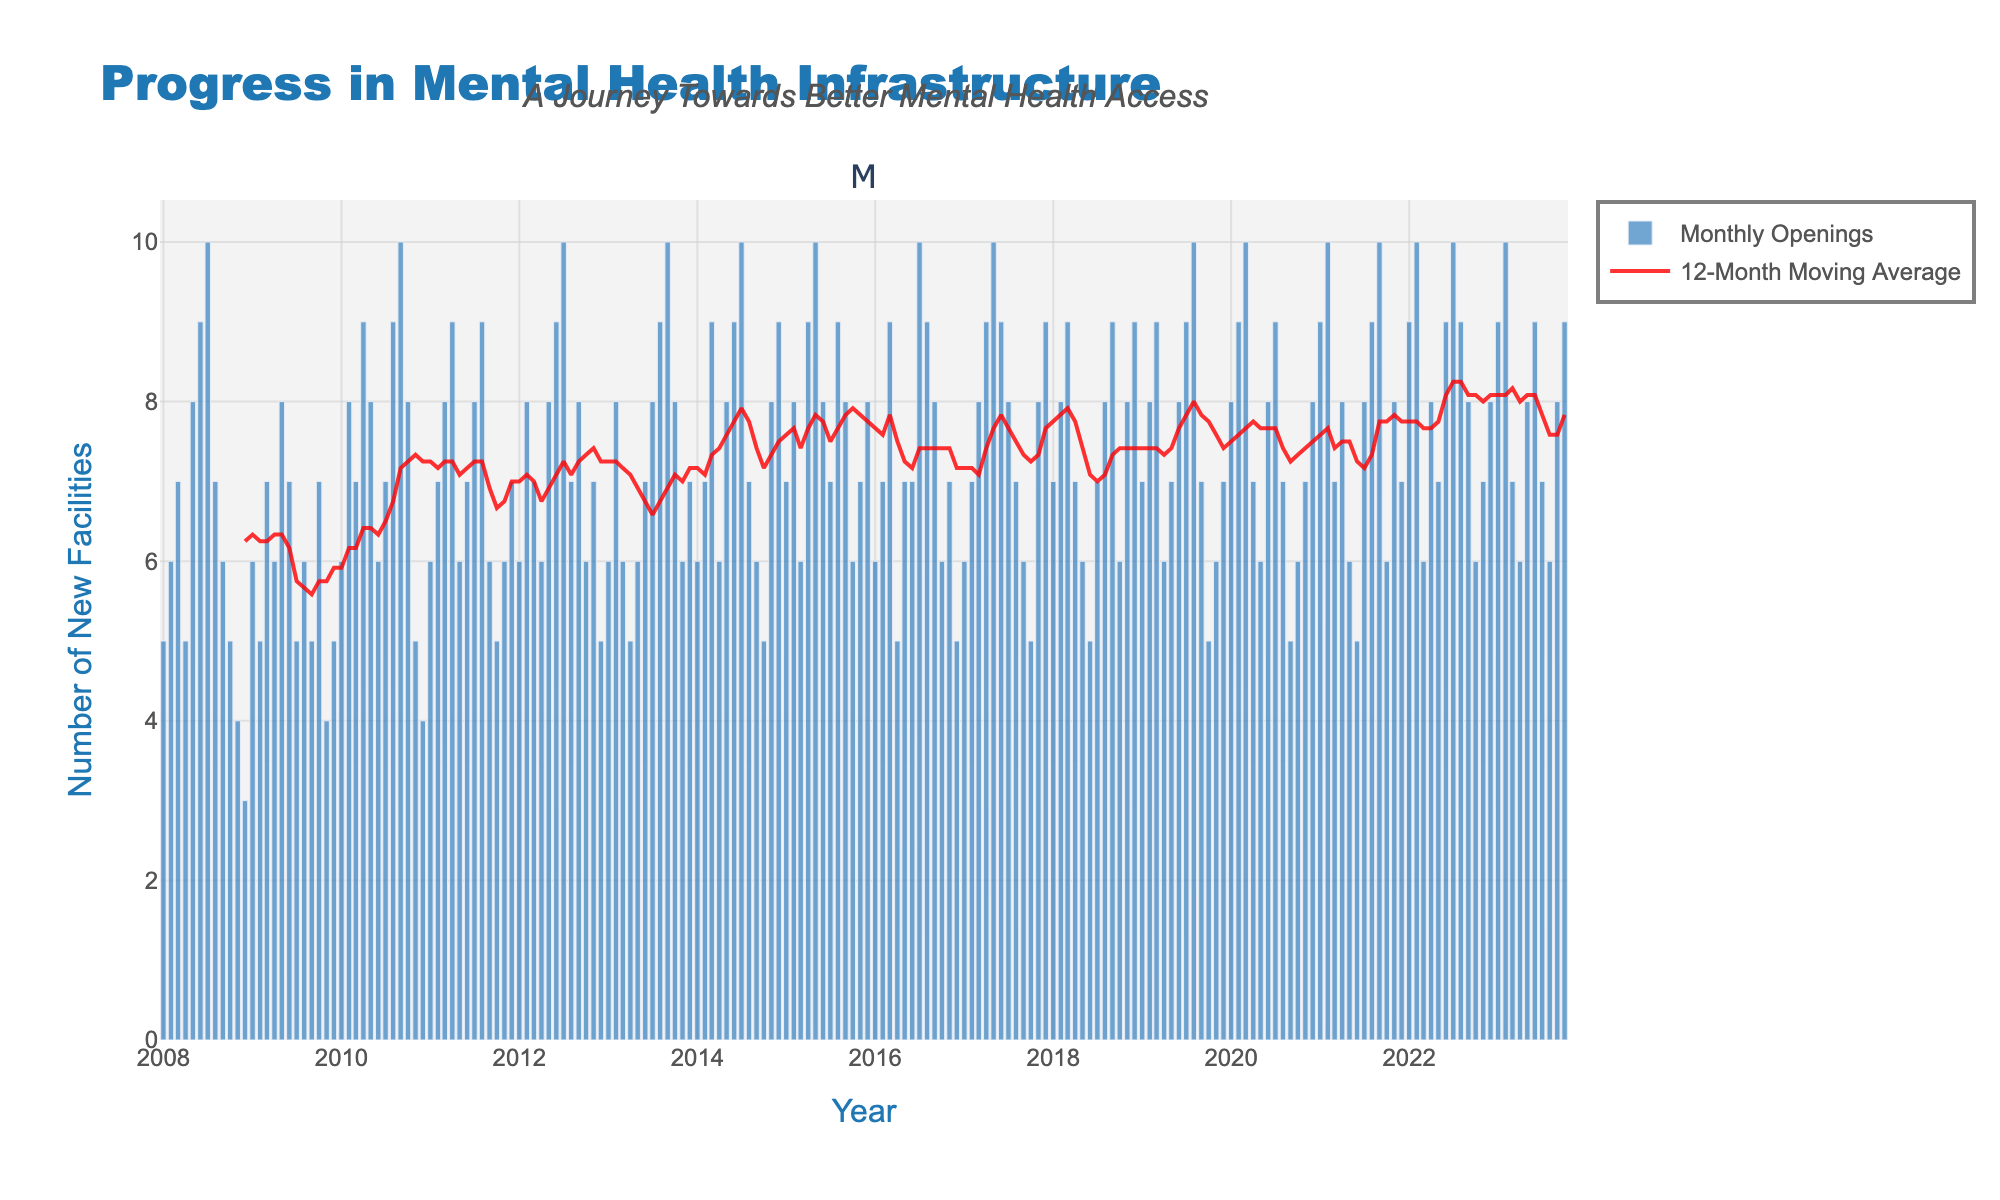What is the title of the figure? The title is found at the top of the figure, providing a summary of what the figure represents. It gives context to the data being shown.
Answer: Progress in Mental Health Infrastructure How many new psychiatric health facilities opened in July 2016? Locate July 2016 on the x-axis, then find the corresponding bar value on the y-axis.
Answer: 10 What color is used for the 12-month moving average line? The 12-month moving average line is differentiated by its color from other elements in the plot.
Answer: Red What was the highest number of new facilities opened in a single month over the 15 years? Check the highest value depicted by the bars across the entire plot period.
Answer: 10 How does the number of new facilities opened in January 2015 compare to December 2014? Find the values for January 2015 and December 2014 and compare them.
Answer: January 2015: 7, December 2014: 9. January 2015 has fewer openings Which year had the lowest annual sum of new psychiatric health facility openings? Sum the monthly openings for each year and compare them to find the lowest sum.
Answer: 2008 What is the trend of the 12-month moving average from 2020 to 2023? Observe the line plot of the 12-month moving average during the specified period to determine the trend direction.
Answer: Stable with minor fluctuations How many months did it take for the number of new facilities opened to generally recover after a drop in late 2008? Identify the initial drop in late 2008, and find how many months it took for the number to rise consistently again.
Answer: Approximately 6 months What is the overall trend in new psychiatric health facility openings over the 15-year period? Examine the overall pattern in the bar heights from the beginning to the end of the plot.
Answer: Increasing trend What is the visible pattern or seasonality in the number of new facilities opened over the years? Look for repeating patterns or cycles in the bar heights over each year.
Answer: Seasonal peaks and troughs 